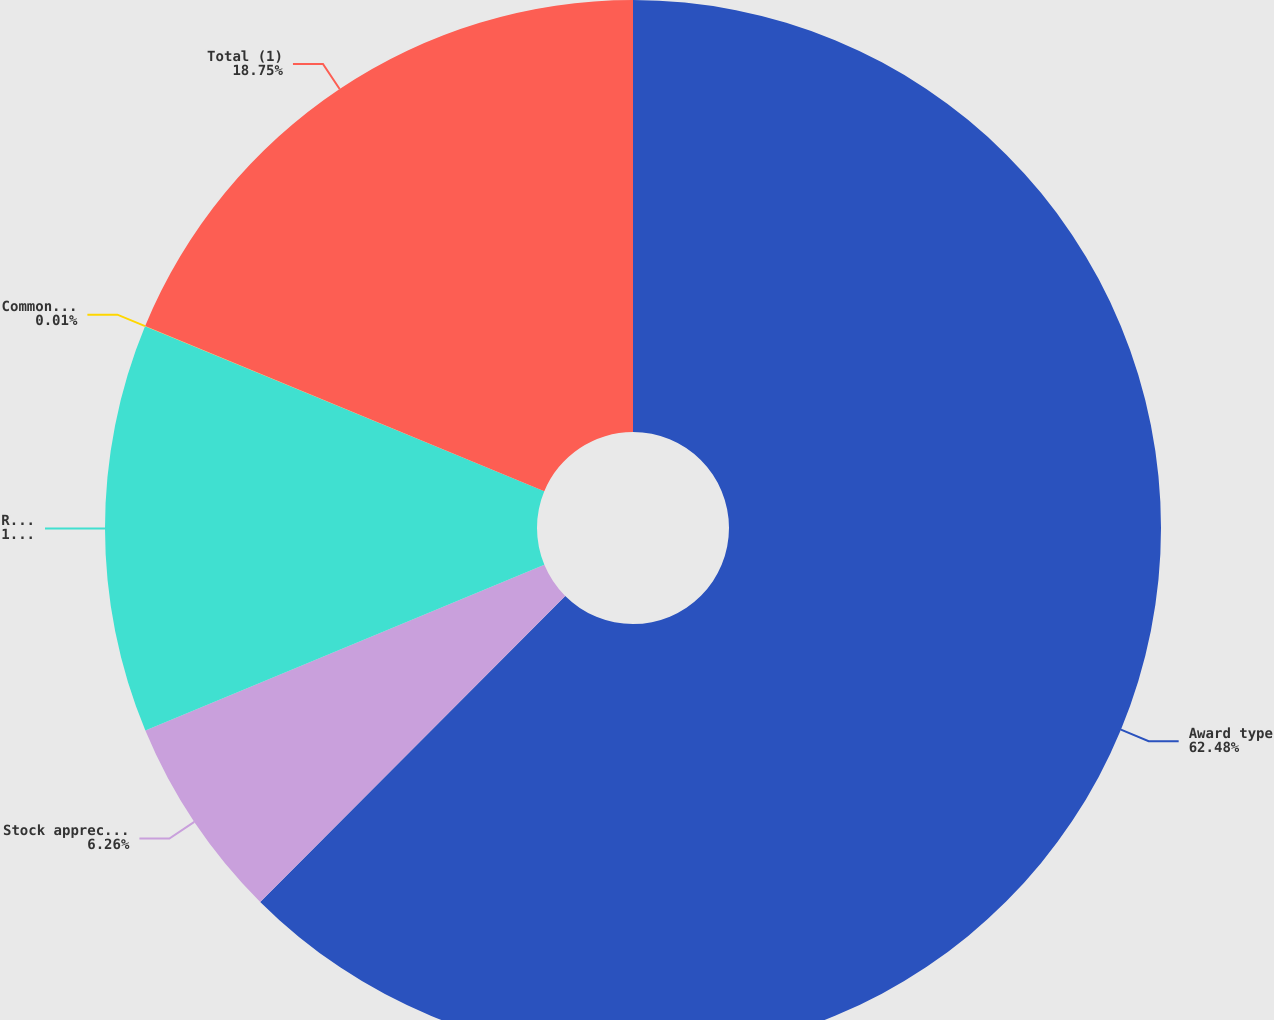<chart> <loc_0><loc_0><loc_500><loc_500><pie_chart><fcel>Award type<fcel>Stock appreciation rights<fcel>Restricted stock units (RSUs)<fcel>Common stock equivalents<fcel>Total (1)<nl><fcel>62.47%<fcel>6.26%<fcel>12.5%<fcel>0.01%<fcel>18.75%<nl></chart> 